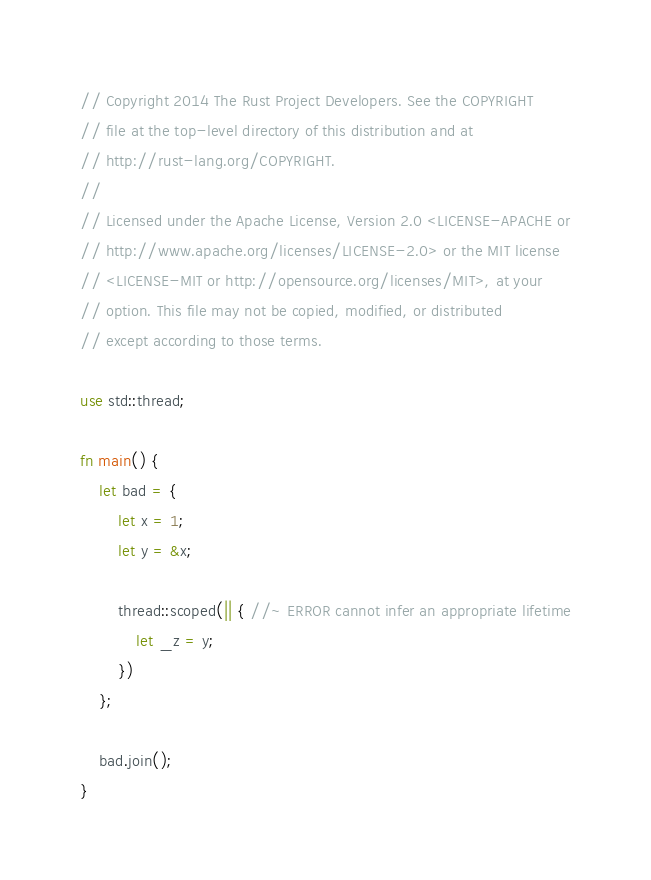Convert code to text. <code><loc_0><loc_0><loc_500><loc_500><_Rust_>// Copyright 2014 The Rust Project Developers. See the COPYRIGHT
// file at the top-level directory of this distribution and at
// http://rust-lang.org/COPYRIGHT.
//
// Licensed under the Apache License, Version 2.0 <LICENSE-APACHE or
// http://www.apache.org/licenses/LICENSE-2.0> or the MIT license
// <LICENSE-MIT or http://opensource.org/licenses/MIT>, at your
// option. This file may not be copied, modified, or distributed
// except according to those terms.

use std::thread;

fn main() {
    let bad = {
        let x = 1;
        let y = &x;

        thread::scoped(|| { //~ ERROR cannot infer an appropriate lifetime
            let _z = y;
        })
    };

    bad.join();
}
</code> 